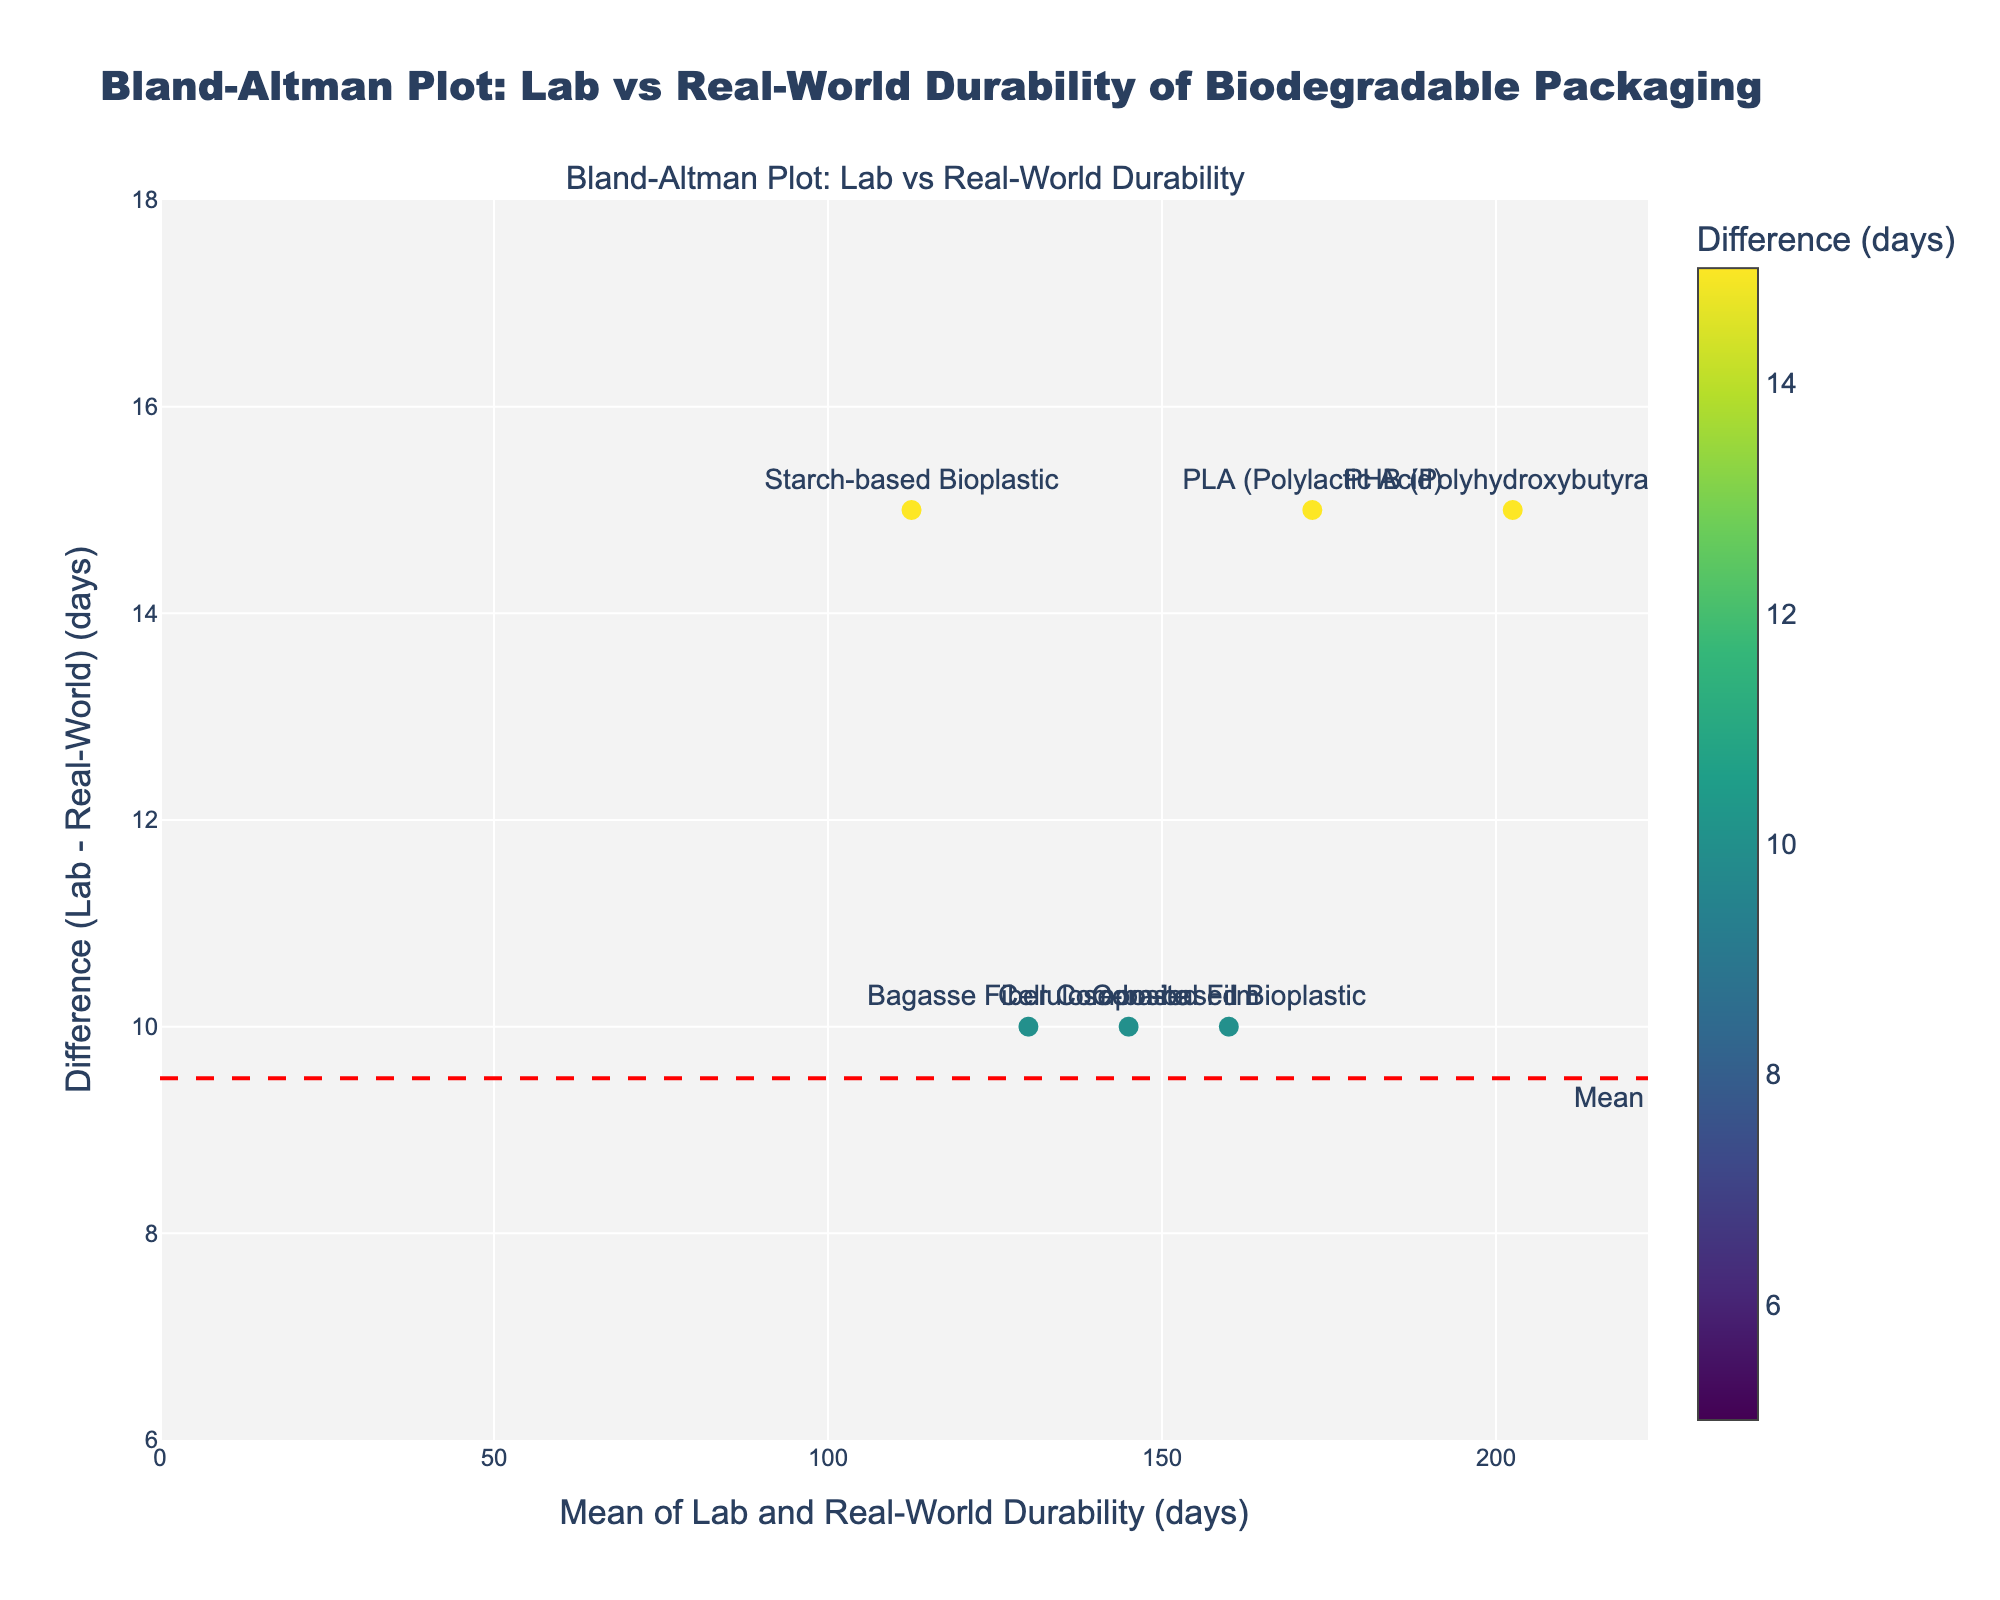What is the title of the plot? The title of the plot is at the top of the figure and is the largest text. It reads "Bland-Altman Plot: Lab vs Real-World Durability of Biodegradable Packaging".
Answer: Bland-Altman Plot: Lab vs Real-World Durability of Biodegradable Packaging How many data points are shown in the plot? There are multiple markers on the plot, each representing a different packaging material. By counting them, we find that there are 10 data points.
Answer: 10 Which material shows the largest positive difference between lab and real-world durability? By analyzing the y-axis (Difference), the highest positive point corresponds to PHB (Polyhydroxybutyrate), indicating the largest positive difference.
Answer: PHB (Polyhydroxybutyrate) What is the range of the mean values of lab and real-world durability shown in the x-axis? The x-axis represents the mean of lab and real-world durability. By observing the data points, the range goes from approximately 57.5 days to 202.5 days.
Answer: 57.5 to 202.5 days What is the mean difference between lab and real-world durability? The mean difference is marked by a red dashed line on the plot, and the annotation at the dashed line states "Mean". This line is located approximately at 10 days.
Answer: 10 days What are the limits of agreement in the plot? The limits of agreement are represented by green dotted lines. The annotations "-1.96 SD" and "+1.96 SD" are positioned at these lines, which are approximately -7.5 days and 27.5 days.
Answer: -7.5 days and 27.5 days Which material is closest to the mean difference line? By identifying the data point closest to the red dashed line (mean difference), we find that PLA (Polylactic Acid) is closest to this line.
Answer: PLA (Polylactic Acid) Is there a material whose lab durability is exactly equal to its real-world durability? The y-axis represents the difference between lab and real-world durability. No data points are located at y = 0, indicating no material has equal lab and real-world durability.
Answer: No Which material's durability shows no more than a 5-day difference between lab and real-world conditions? By examining the y-axis values within the range of ±5 days, the materials closest to y = 0 within this range are Bamboo Fiber Packaging and Mycelium Packaging.
Answer: Bamboo Fiber Packaging and Mycelium Packaging 